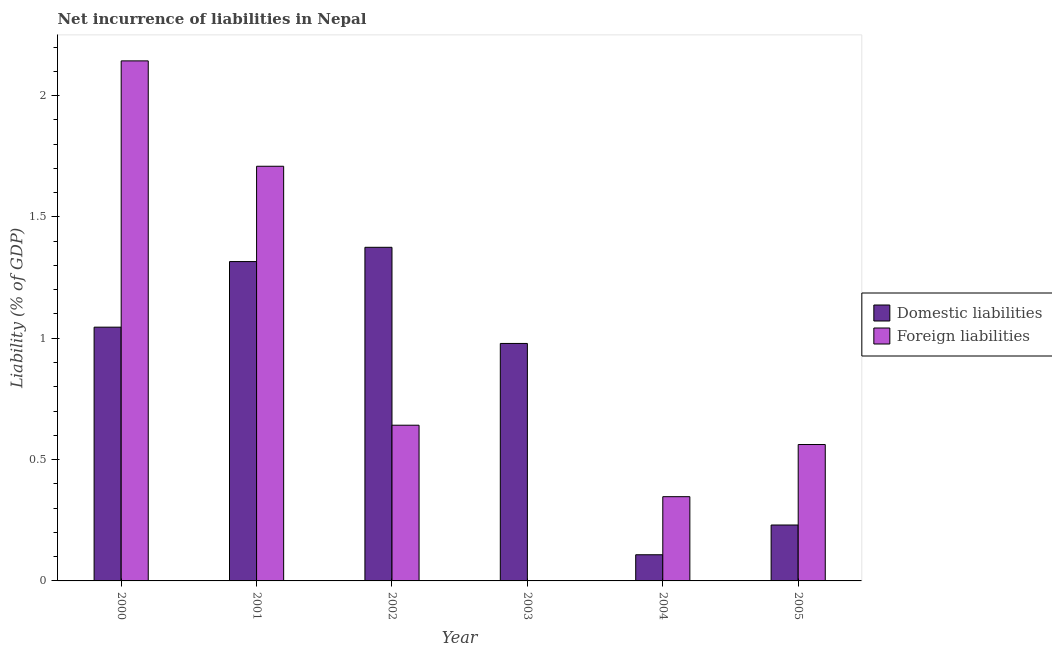What is the label of the 4th group of bars from the left?
Offer a terse response. 2003. What is the incurrence of foreign liabilities in 2002?
Your answer should be compact. 0.64. Across all years, what is the maximum incurrence of domestic liabilities?
Provide a short and direct response. 1.37. What is the total incurrence of foreign liabilities in the graph?
Give a very brief answer. 5.4. What is the difference between the incurrence of foreign liabilities in 2002 and that in 2005?
Make the answer very short. 0.08. What is the difference between the incurrence of domestic liabilities in 2000 and the incurrence of foreign liabilities in 2003?
Ensure brevity in your answer.  0.07. What is the average incurrence of domestic liabilities per year?
Offer a terse response. 0.84. In the year 2002, what is the difference between the incurrence of foreign liabilities and incurrence of domestic liabilities?
Ensure brevity in your answer.  0. In how many years, is the incurrence of foreign liabilities greater than 1.2 %?
Ensure brevity in your answer.  2. What is the ratio of the incurrence of domestic liabilities in 2001 to that in 2002?
Your answer should be compact. 0.96. What is the difference between the highest and the second highest incurrence of foreign liabilities?
Provide a succinct answer. 0.43. What is the difference between the highest and the lowest incurrence of domestic liabilities?
Provide a succinct answer. 1.27. Is the sum of the incurrence of domestic liabilities in 2000 and 2001 greater than the maximum incurrence of foreign liabilities across all years?
Offer a very short reply. Yes. How many bars are there?
Ensure brevity in your answer.  11. Does the graph contain any zero values?
Your response must be concise. Yes. How are the legend labels stacked?
Ensure brevity in your answer.  Vertical. What is the title of the graph?
Your response must be concise. Net incurrence of liabilities in Nepal. Does "GDP at market prices" appear as one of the legend labels in the graph?
Ensure brevity in your answer.  No. What is the label or title of the X-axis?
Ensure brevity in your answer.  Year. What is the label or title of the Y-axis?
Make the answer very short. Liability (% of GDP). What is the Liability (% of GDP) in Domestic liabilities in 2000?
Offer a very short reply. 1.05. What is the Liability (% of GDP) of Foreign liabilities in 2000?
Your response must be concise. 2.14. What is the Liability (% of GDP) in Domestic liabilities in 2001?
Offer a very short reply. 1.32. What is the Liability (% of GDP) of Foreign liabilities in 2001?
Provide a short and direct response. 1.71. What is the Liability (% of GDP) in Domestic liabilities in 2002?
Your answer should be very brief. 1.37. What is the Liability (% of GDP) of Foreign liabilities in 2002?
Make the answer very short. 0.64. What is the Liability (% of GDP) of Domestic liabilities in 2003?
Your answer should be compact. 0.98. What is the Liability (% of GDP) of Foreign liabilities in 2003?
Offer a terse response. 0. What is the Liability (% of GDP) in Domestic liabilities in 2004?
Offer a terse response. 0.11. What is the Liability (% of GDP) in Foreign liabilities in 2004?
Your answer should be very brief. 0.35. What is the Liability (% of GDP) of Domestic liabilities in 2005?
Your answer should be very brief. 0.23. What is the Liability (% of GDP) of Foreign liabilities in 2005?
Make the answer very short. 0.56. Across all years, what is the maximum Liability (% of GDP) of Domestic liabilities?
Give a very brief answer. 1.37. Across all years, what is the maximum Liability (% of GDP) of Foreign liabilities?
Your answer should be very brief. 2.14. Across all years, what is the minimum Liability (% of GDP) in Domestic liabilities?
Provide a short and direct response. 0.11. Across all years, what is the minimum Liability (% of GDP) in Foreign liabilities?
Make the answer very short. 0. What is the total Liability (% of GDP) of Domestic liabilities in the graph?
Make the answer very short. 5.05. What is the total Liability (% of GDP) in Foreign liabilities in the graph?
Ensure brevity in your answer.  5.4. What is the difference between the Liability (% of GDP) of Domestic liabilities in 2000 and that in 2001?
Provide a succinct answer. -0.27. What is the difference between the Liability (% of GDP) in Foreign liabilities in 2000 and that in 2001?
Keep it short and to the point. 0.43. What is the difference between the Liability (% of GDP) of Domestic liabilities in 2000 and that in 2002?
Your answer should be very brief. -0.33. What is the difference between the Liability (% of GDP) in Foreign liabilities in 2000 and that in 2002?
Ensure brevity in your answer.  1.5. What is the difference between the Liability (% of GDP) of Domestic liabilities in 2000 and that in 2003?
Make the answer very short. 0.07. What is the difference between the Liability (% of GDP) of Domestic liabilities in 2000 and that in 2004?
Keep it short and to the point. 0.94. What is the difference between the Liability (% of GDP) of Foreign liabilities in 2000 and that in 2004?
Give a very brief answer. 1.8. What is the difference between the Liability (% of GDP) in Domestic liabilities in 2000 and that in 2005?
Your answer should be very brief. 0.82. What is the difference between the Liability (% of GDP) of Foreign liabilities in 2000 and that in 2005?
Offer a terse response. 1.58. What is the difference between the Liability (% of GDP) in Domestic liabilities in 2001 and that in 2002?
Offer a very short reply. -0.06. What is the difference between the Liability (% of GDP) in Foreign liabilities in 2001 and that in 2002?
Make the answer very short. 1.07. What is the difference between the Liability (% of GDP) of Domestic liabilities in 2001 and that in 2003?
Your response must be concise. 0.34. What is the difference between the Liability (% of GDP) in Domestic liabilities in 2001 and that in 2004?
Keep it short and to the point. 1.21. What is the difference between the Liability (% of GDP) in Foreign liabilities in 2001 and that in 2004?
Make the answer very short. 1.36. What is the difference between the Liability (% of GDP) in Domestic liabilities in 2001 and that in 2005?
Keep it short and to the point. 1.09. What is the difference between the Liability (% of GDP) in Foreign liabilities in 2001 and that in 2005?
Provide a succinct answer. 1.15. What is the difference between the Liability (% of GDP) in Domestic liabilities in 2002 and that in 2003?
Your response must be concise. 0.4. What is the difference between the Liability (% of GDP) of Domestic liabilities in 2002 and that in 2004?
Keep it short and to the point. 1.27. What is the difference between the Liability (% of GDP) of Foreign liabilities in 2002 and that in 2004?
Make the answer very short. 0.29. What is the difference between the Liability (% of GDP) in Domestic liabilities in 2002 and that in 2005?
Offer a very short reply. 1.14. What is the difference between the Liability (% of GDP) in Foreign liabilities in 2002 and that in 2005?
Make the answer very short. 0.08. What is the difference between the Liability (% of GDP) of Domestic liabilities in 2003 and that in 2004?
Make the answer very short. 0.87. What is the difference between the Liability (% of GDP) in Domestic liabilities in 2003 and that in 2005?
Provide a succinct answer. 0.75. What is the difference between the Liability (% of GDP) of Domestic liabilities in 2004 and that in 2005?
Make the answer very short. -0.12. What is the difference between the Liability (% of GDP) of Foreign liabilities in 2004 and that in 2005?
Your answer should be very brief. -0.21. What is the difference between the Liability (% of GDP) of Domestic liabilities in 2000 and the Liability (% of GDP) of Foreign liabilities in 2001?
Your response must be concise. -0.66. What is the difference between the Liability (% of GDP) of Domestic liabilities in 2000 and the Liability (% of GDP) of Foreign liabilities in 2002?
Provide a short and direct response. 0.4. What is the difference between the Liability (% of GDP) of Domestic liabilities in 2000 and the Liability (% of GDP) of Foreign liabilities in 2004?
Your response must be concise. 0.7. What is the difference between the Liability (% of GDP) in Domestic liabilities in 2000 and the Liability (% of GDP) in Foreign liabilities in 2005?
Your answer should be compact. 0.48. What is the difference between the Liability (% of GDP) of Domestic liabilities in 2001 and the Liability (% of GDP) of Foreign liabilities in 2002?
Your answer should be compact. 0.67. What is the difference between the Liability (% of GDP) in Domestic liabilities in 2001 and the Liability (% of GDP) in Foreign liabilities in 2004?
Offer a very short reply. 0.97. What is the difference between the Liability (% of GDP) in Domestic liabilities in 2001 and the Liability (% of GDP) in Foreign liabilities in 2005?
Make the answer very short. 0.75. What is the difference between the Liability (% of GDP) of Domestic liabilities in 2002 and the Liability (% of GDP) of Foreign liabilities in 2004?
Your answer should be compact. 1.03. What is the difference between the Liability (% of GDP) in Domestic liabilities in 2002 and the Liability (% of GDP) in Foreign liabilities in 2005?
Provide a succinct answer. 0.81. What is the difference between the Liability (% of GDP) of Domestic liabilities in 2003 and the Liability (% of GDP) of Foreign liabilities in 2004?
Provide a short and direct response. 0.63. What is the difference between the Liability (% of GDP) in Domestic liabilities in 2003 and the Liability (% of GDP) in Foreign liabilities in 2005?
Your response must be concise. 0.42. What is the difference between the Liability (% of GDP) of Domestic liabilities in 2004 and the Liability (% of GDP) of Foreign liabilities in 2005?
Keep it short and to the point. -0.45. What is the average Liability (% of GDP) of Domestic liabilities per year?
Your answer should be compact. 0.84. What is the average Liability (% of GDP) in Foreign liabilities per year?
Ensure brevity in your answer.  0.9. In the year 2000, what is the difference between the Liability (% of GDP) in Domestic liabilities and Liability (% of GDP) in Foreign liabilities?
Offer a terse response. -1.1. In the year 2001, what is the difference between the Liability (% of GDP) of Domestic liabilities and Liability (% of GDP) of Foreign liabilities?
Offer a terse response. -0.39. In the year 2002, what is the difference between the Liability (% of GDP) of Domestic liabilities and Liability (% of GDP) of Foreign liabilities?
Your response must be concise. 0.73. In the year 2004, what is the difference between the Liability (% of GDP) in Domestic liabilities and Liability (% of GDP) in Foreign liabilities?
Offer a terse response. -0.24. In the year 2005, what is the difference between the Liability (% of GDP) of Domestic liabilities and Liability (% of GDP) of Foreign liabilities?
Offer a terse response. -0.33. What is the ratio of the Liability (% of GDP) in Domestic liabilities in 2000 to that in 2001?
Keep it short and to the point. 0.79. What is the ratio of the Liability (% of GDP) in Foreign liabilities in 2000 to that in 2001?
Provide a short and direct response. 1.25. What is the ratio of the Liability (% of GDP) in Domestic liabilities in 2000 to that in 2002?
Provide a short and direct response. 0.76. What is the ratio of the Liability (% of GDP) in Foreign liabilities in 2000 to that in 2002?
Your answer should be very brief. 3.34. What is the ratio of the Liability (% of GDP) of Domestic liabilities in 2000 to that in 2003?
Offer a terse response. 1.07. What is the ratio of the Liability (% of GDP) in Domestic liabilities in 2000 to that in 2004?
Give a very brief answer. 9.7. What is the ratio of the Liability (% of GDP) of Foreign liabilities in 2000 to that in 2004?
Your answer should be very brief. 6.17. What is the ratio of the Liability (% of GDP) in Domestic liabilities in 2000 to that in 2005?
Ensure brevity in your answer.  4.54. What is the ratio of the Liability (% of GDP) in Foreign liabilities in 2000 to that in 2005?
Keep it short and to the point. 3.81. What is the ratio of the Liability (% of GDP) of Domestic liabilities in 2001 to that in 2002?
Give a very brief answer. 0.96. What is the ratio of the Liability (% of GDP) in Foreign liabilities in 2001 to that in 2002?
Keep it short and to the point. 2.66. What is the ratio of the Liability (% of GDP) of Domestic liabilities in 2001 to that in 2003?
Give a very brief answer. 1.34. What is the ratio of the Liability (% of GDP) of Domestic liabilities in 2001 to that in 2004?
Ensure brevity in your answer.  12.2. What is the ratio of the Liability (% of GDP) of Foreign liabilities in 2001 to that in 2004?
Keep it short and to the point. 4.92. What is the ratio of the Liability (% of GDP) of Domestic liabilities in 2001 to that in 2005?
Offer a terse response. 5.71. What is the ratio of the Liability (% of GDP) in Foreign liabilities in 2001 to that in 2005?
Your response must be concise. 3.04. What is the ratio of the Liability (% of GDP) of Domestic liabilities in 2002 to that in 2003?
Give a very brief answer. 1.4. What is the ratio of the Liability (% of GDP) in Domestic liabilities in 2002 to that in 2004?
Provide a short and direct response. 12.75. What is the ratio of the Liability (% of GDP) of Foreign liabilities in 2002 to that in 2004?
Give a very brief answer. 1.85. What is the ratio of the Liability (% of GDP) of Domestic liabilities in 2002 to that in 2005?
Provide a succinct answer. 5.97. What is the ratio of the Liability (% of GDP) of Foreign liabilities in 2002 to that in 2005?
Make the answer very short. 1.14. What is the ratio of the Liability (% of GDP) of Domestic liabilities in 2003 to that in 2004?
Your answer should be very brief. 9.07. What is the ratio of the Liability (% of GDP) in Domestic liabilities in 2003 to that in 2005?
Provide a short and direct response. 4.25. What is the ratio of the Liability (% of GDP) in Domestic liabilities in 2004 to that in 2005?
Ensure brevity in your answer.  0.47. What is the ratio of the Liability (% of GDP) in Foreign liabilities in 2004 to that in 2005?
Make the answer very short. 0.62. What is the difference between the highest and the second highest Liability (% of GDP) of Domestic liabilities?
Your response must be concise. 0.06. What is the difference between the highest and the second highest Liability (% of GDP) of Foreign liabilities?
Make the answer very short. 0.43. What is the difference between the highest and the lowest Liability (% of GDP) of Domestic liabilities?
Keep it short and to the point. 1.27. What is the difference between the highest and the lowest Liability (% of GDP) in Foreign liabilities?
Offer a terse response. 2.14. 